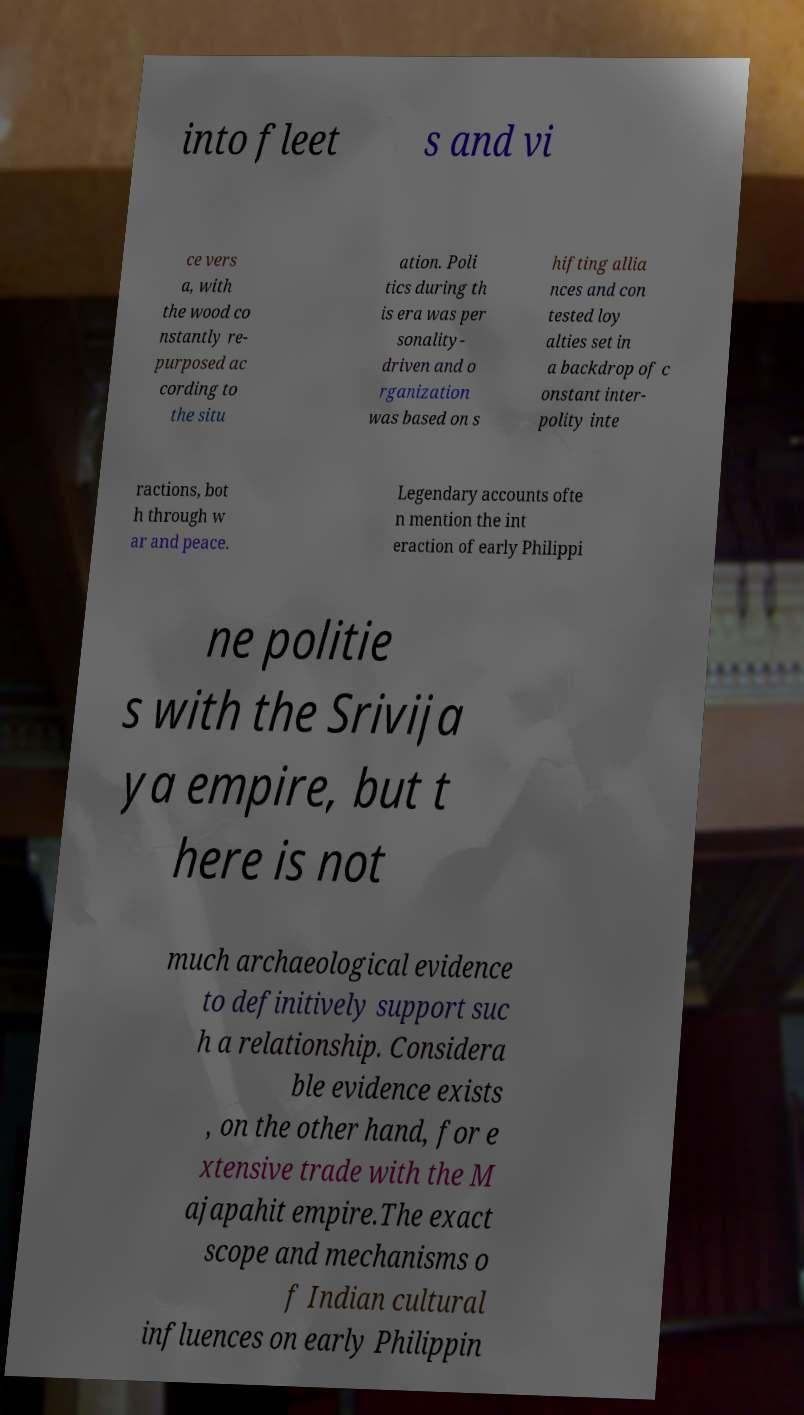What messages or text are displayed in this image? I need them in a readable, typed format. into fleet s and vi ce vers a, with the wood co nstantly re- purposed ac cording to the situ ation. Poli tics during th is era was per sonality- driven and o rganization was based on s hifting allia nces and con tested loy alties set in a backdrop of c onstant inter- polity inte ractions, bot h through w ar and peace. Legendary accounts ofte n mention the int eraction of early Philippi ne politie s with the Srivija ya empire, but t here is not much archaeological evidence to definitively support suc h a relationship. Considera ble evidence exists , on the other hand, for e xtensive trade with the M ajapahit empire.The exact scope and mechanisms o f Indian cultural influences on early Philippin 